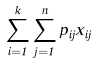Convert formula to latex. <formula><loc_0><loc_0><loc_500><loc_500>\sum _ { i = 1 } ^ { k } \sum _ { j = 1 } ^ { n } p _ { i j } x _ { i j }</formula> 